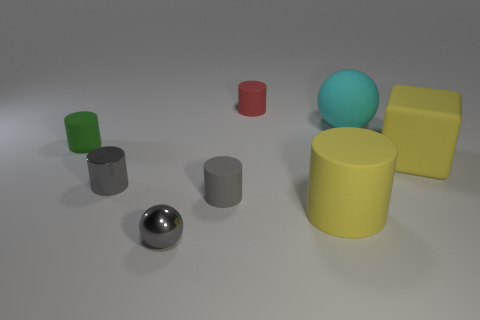Add 2 matte cylinders. How many objects exist? 10 Subtract all spheres. How many objects are left? 6 Subtract all small gray cylinders. How many cylinders are left? 3 Subtract 0 purple cylinders. How many objects are left? 8 Subtract 3 cylinders. How many cylinders are left? 2 Subtract all yellow spheres. Subtract all green cubes. How many spheres are left? 2 Subtract all purple spheres. How many red cubes are left? 0 Subtract all big yellow rubber cylinders. Subtract all small green things. How many objects are left? 6 Add 3 yellow matte cubes. How many yellow matte cubes are left? 4 Add 2 rubber objects. How many rubber objects exist? 8 